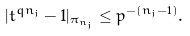<formula> <loc_0><loc_0><loc_500><loc_500>| t ^ { q n _ { j } } - 1 | _ { \pi _ { n _ { j } } } \leq p ^ { - ( n _ { j } - 1 ) } .</formula> 